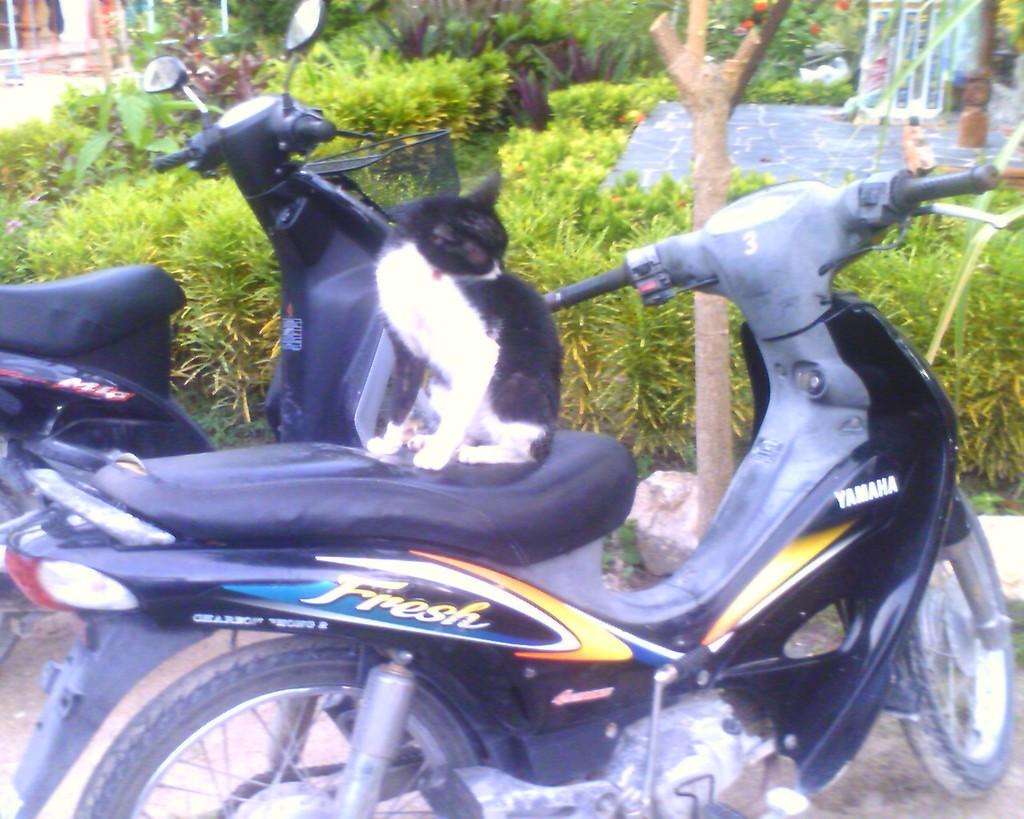Describe this image in one or two sentences. in the picture we can see two bike ,on one bike a cat is sitting there is garden behind the bike. 